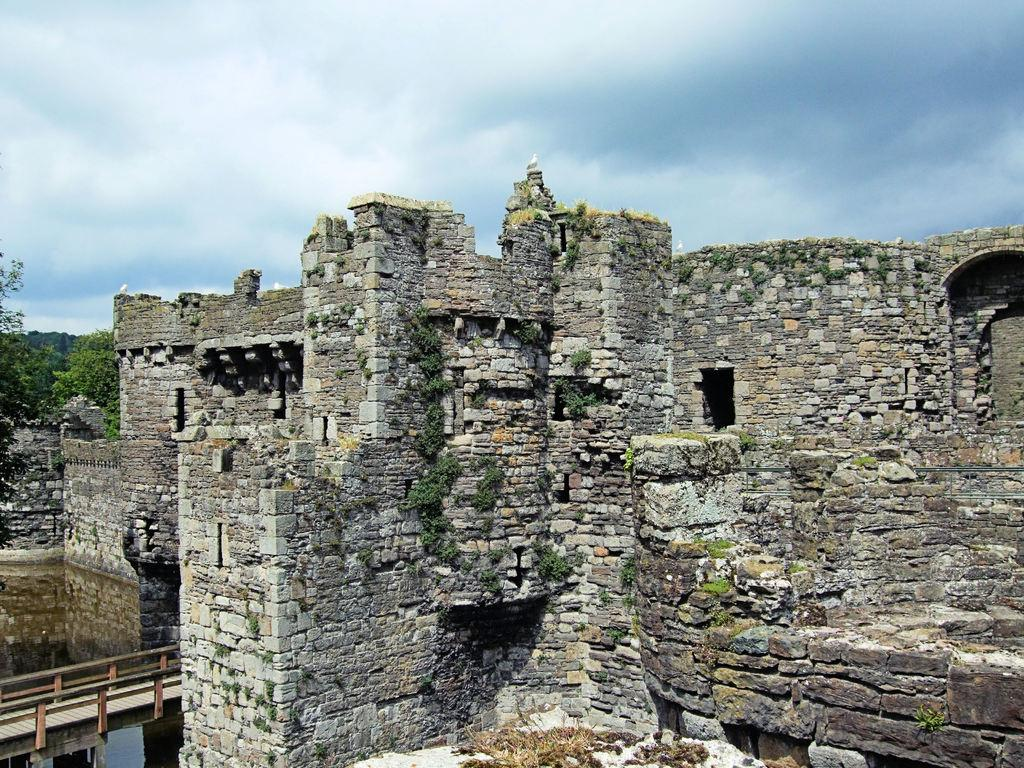What type of structure is present in the image? There is a fort in the image. What can be seen near the fort? There is a railing visible in the image. What is present in front of the fort? There is water in the image. What can be seen in the background of the image? There are many trees and clouds in the background of the image, and the sky is also visible. What type of pollution can be seen in the image? There is no pollution visible in the image. What type of yam is being used to build the fort in the image? There is no yam present in the image, and yams are not used for building forts. 